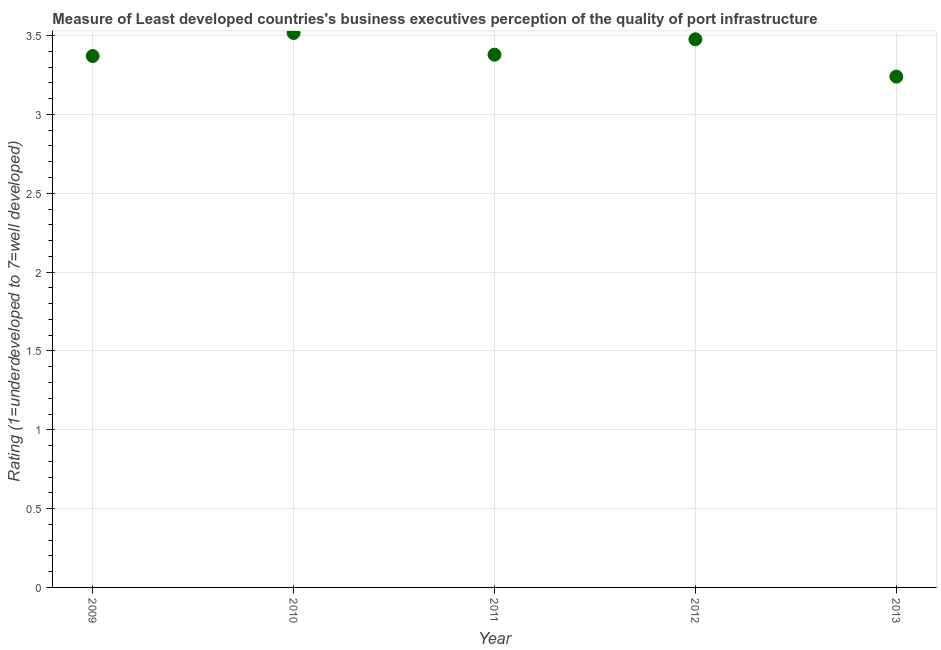What is the rating measuring quality of port infrastructure in 2011?
Your answer should be compact. 3.38. Across all years, what is the maximum rating measuring quality of port infrastructure?
Offer a terse response. 3.52. Across all years, what is the minimum rating measuring quality of port infrastructure?
Give a very brief answer. 3.24. In which year was the rating measuring quality of port infrastructure minimum?
Make the answer very short. 2013. What is the sum of the rating measuring quality of port infrastructure?
Your answer should be compact. 16.98. What is the difference between the rating measuring quality of port infrastructure in 2010 and 2012?
Keep it short and to the point. 0.04. What is the average rating measuring quality of port infrastructure per year?
Offer a terse response. 3.4. What is the median rating measuring quality of port infrastructure?
Your answer should be very brief. 3.38. What is the ratio of the rating measuring quality of port infrastructure in 2009 to that in 2011?
Give a very brief answer. 1. Is the rating measuring quality of port infrastructure in 2011 less than that in 2012?
Make the answer very short. Yes. What is the difference between the highest and the second highest rating measuring quality of port infrastructure?
Your answer should be very brief. 0.04. What is the difference between the highest and the lowest rating measuring quality of port infrastructure?
Keep it short and to the point. 0.28. What is the difference between two consecutive major ticks on the Y-axis?
Provide a succinct answer. 0.5. Are the values on the major ticks of Y-axis written in scientific E-notation?
Make the answer very short. No. Does the graph contain grids?
Offer a terse response. Yes. What is the title of the graph?
Give a very brief answer. Measure of Least developed countries's business executives perception of the quality of port infrastructure. What is the label or title of the Y-axis?
Your answer should be compact. Rating (1=underdeveloped to 7=well developed) . What is the Rating (1=underdeveloped to 7=well developed)  in 2009?
Provide a short and direct response. 3.37. What is the Rating (1=underdeveloped to 7=well developed)  in 2010?
Make the answer very short. 3.52. What is the Rating (1=underdeveloped to 7=well developed)  in 2011?
Your answer should be very brief. 3.38. What is the Rating (1=underdeveloped to 7=well developed)  in 2012?
Your response must be concise. 3.48. What is the Rating (1=underdeveloped to 7=well developed)  in 2013?
Provide a succinct answer. 3.24. What is the difference between the Rating (1=underdeveloped to 7=well developed)  in 2009 and 2010?
Offer a terse response. -0.15. What is the difference between the Rating (1=underdeveloped to 7=well developed)  in 2009 and 2011?
Offer a very short reply. -0.01. What is the difference between the Rating (1=underdeveloped to 7=well developed)  in 2009 and 2012?
Offer a terse response. -0.11. What is the difference between the Rating (1=underdeveloped to 7=well developed)  in 2009 and 2013?
Provide a short and direct response. 0.13. What is the difference between the Rating (1=underdeveloped to 7=well developed)  in 2010 and 2011?
Ensure brevity in your answer.  0.14. What is the difference between the Rating (1=underdeveloped to 7=well developed)  in 2010 and 2012?
Provide a succinct answer. 0.04. What is the difference between the Rating (1=underdeveloped to 7=well developed)  in 2010 and 2013?
Offer a very short reply. 0.28. What is the difference between the Rating (1=underdeveloped to 7=well developed)  in 2011 and 2012?
Provide a short and direct response. -0.1. What is the difference between the Rating (1=underdeveloped to 7=well developed)  in 2011 and 2013?
Offer a very short reply. 0.14. What is the difference between the Rating (1=underdeveloped to 7=well developed)  in 2012 and 2013?
Provide a succinct answer. 0.24. What is the ratio of the Rating (1=underdeveloped to 7=well developed)  in 2009 to that in 2010?
Offer a terse response. 0.96. What is the ratio of the Rating (1=underdeveloped to 7=well developed)  in 2009 to that in 2012?
Ensure brevity in your answer.  0.97. What is the ratio of the Rating (1=underdeveloped to 7=well developed)  in 2009 to that in 2013?
Provide a short and direct response. 1.04. What is the ratio of the Rating (1=underdeveloped to 7=well developed)  in 2010 to that in 2011?
Offer a very short reply. 1.04. What is the ratio of the Rating (1=underdeveloped to 7=well developed)  in 2010 to that in 2012?
Your response must be concise. 1.01. What is the ratio of the Rating (1=underdeveloped to 7=well developed)  in 2010 to that in 2013?
Your response must be concise. 1.08. What is the ratio of the Rating (1=underdeveloped to 7=well developed)  in 2011 to that in 2012?
Offer a very short reply. 0.97. What is the ratio of the Rating (1=underdeveloped to 7=well developed)  in 2011 to that in 2013?
Provide a succinct answer. 1.04. What is the ratio of the Rating (1=underdeveloped to 7=well developed)  in 2012 to that in 2013?
Your answer should be compact. 1.07. 